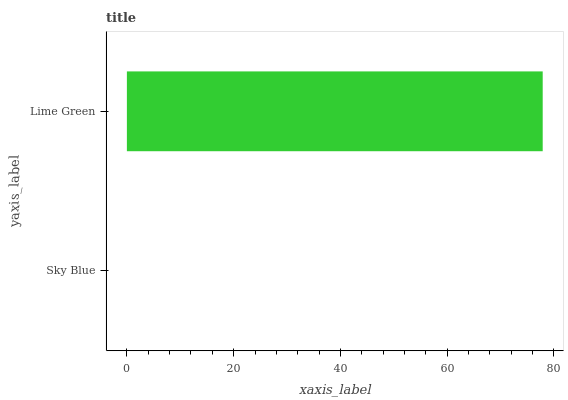Is Sky Blue the minimum?
Answer yes or no. Yes. Is Lime Green the maximum?
Answer yes or no. Yes. Is Lime Green the minimum?
Answer yes or no. No. Is Lime Green greater than Sky Blue?
Answer yes or no. Yes. Is Sky Blue less than Lime Green?
Answer yes or no. Yes. Is Sky Blue greater than Lime Green?
Answer yes or no. No. Is Lime Green less than Sky Blue?
Answer yes or no. No. Is Lime Green the high median?
Answer yes or no. Yes. Is Sky Blue the low median?
Answer yes or no. Yes. Is Sky Blue the high median?
Answer yes or no. No. Is Lime Green the low median?
Answer yes or no. No. 